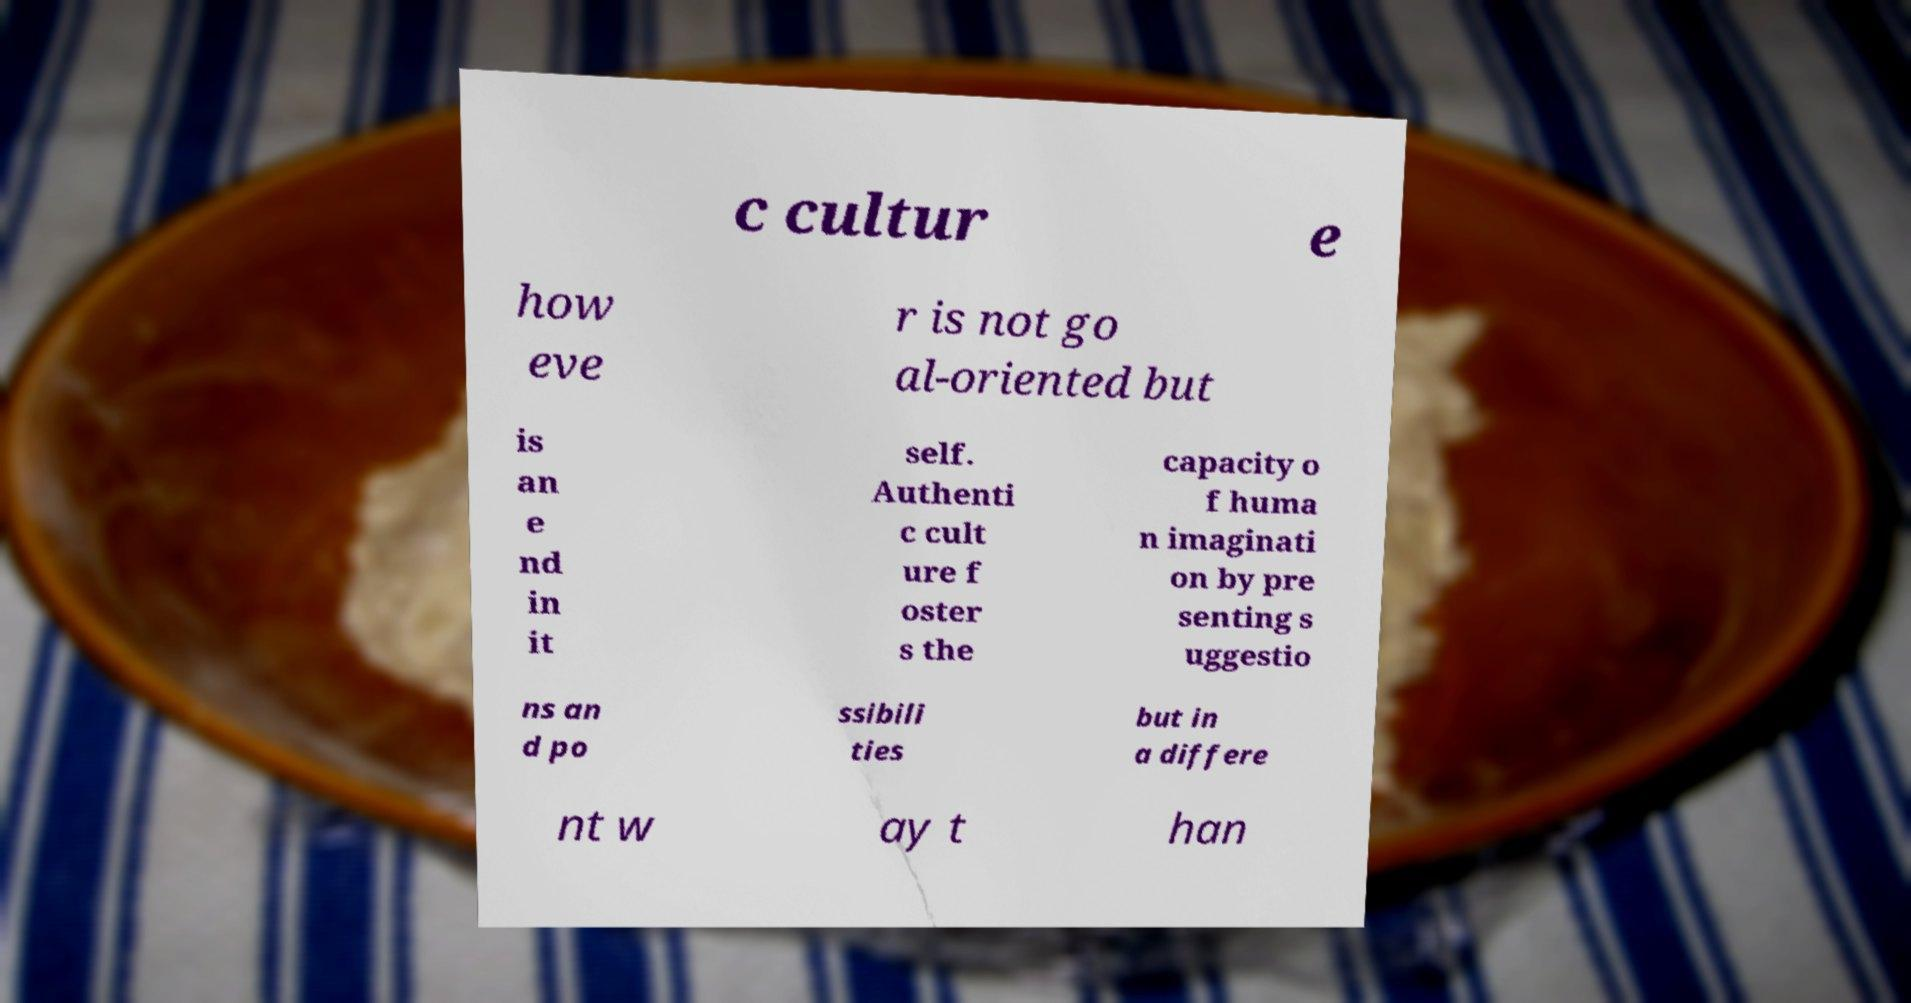Can you read and provide the text displayed in the image?This photo seems to have some interesting text. Can you extract and type it out for me? c cultur e how eve r is not go al-oriented but is an e nd in it self. Authenti c cult ure f oster s the capacity o f huma n imaginati on by pre senting s uggestio ns an d po ssibili ties but in a differe nt w ay t han 